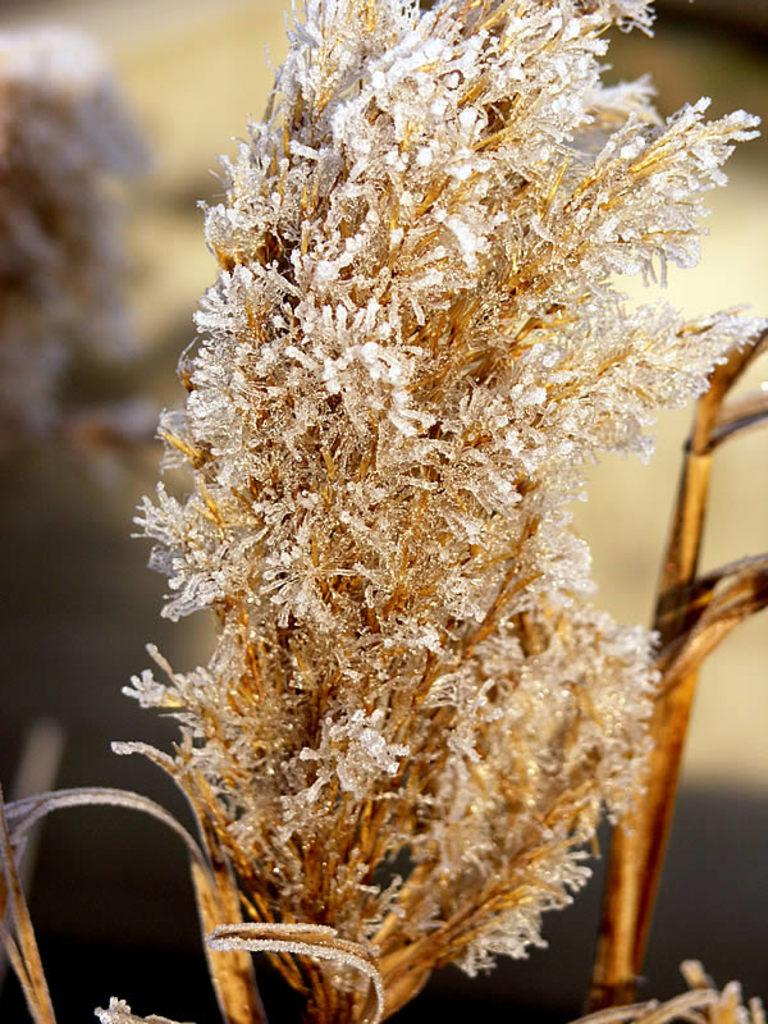What type of flowers are in the image? There is a bunch of white and golden color dry flowers in the image. Can you describe the background of the image? The background of the image is blurred. What type of legal advice can be obtained from the pet in the image? There is no pet present in the image, and therefore no legal advice can be obtained. Can you describe the cave in the image? There is no cave present in the image. 